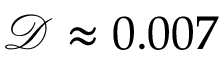<formula> <loc_0><loc_0><loc_500><loc_500>\mathcal { D } \approx 0 . 0 0 7</formula> 